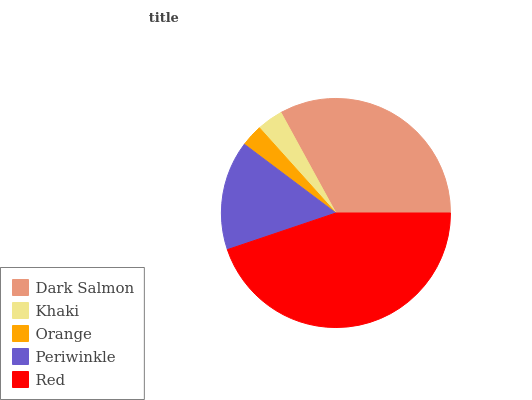Is Orange the minimum?
Answer yes or no. Yes. Is Red the maximum?
Answer yes or no. Yes. Is Khaki the minimum?
Answer yes or no. No. Is Khaki the maximum?
Answer yes or no. No. Is Dark Salmon greater than Khaki?
Answer yes or no. Yes. Is Khaki less than Dark Salmon?
Answer yes or no. Yes. Is Khaki greater than Dark Salmon?
Answer yes or no. No. Is Dark Salmon less than Khaki?
Answer yes or no. No. Is Periwinkle the high median?
Answer yes or no. Yes. Is Periwinkle the low median?
Answer yes or no. Yes. Is Red the high median?
Answer yes or no. No. Is Khaki the low median?
Answer yes or no. No. 